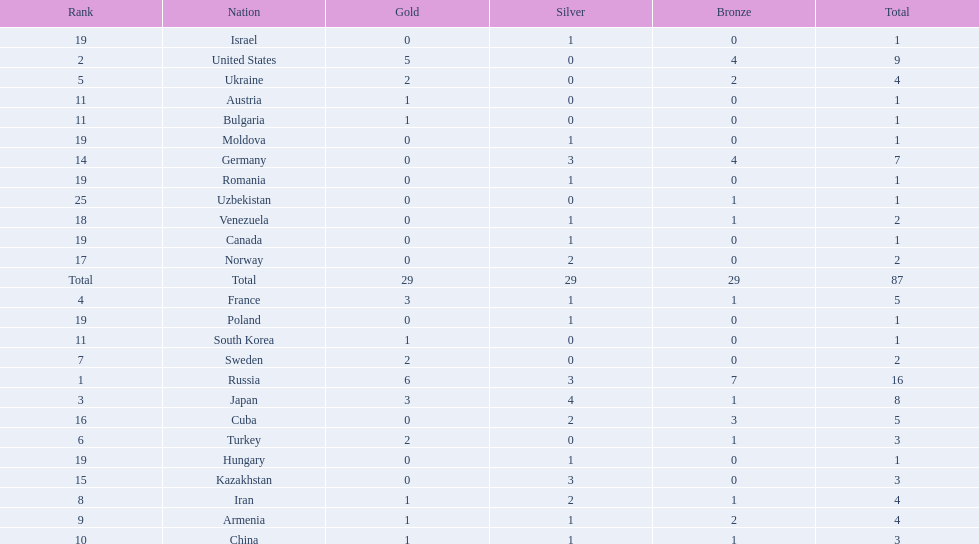How many gold medals did the united states win? 5. Who won more than 5 gold medals? Russia. 